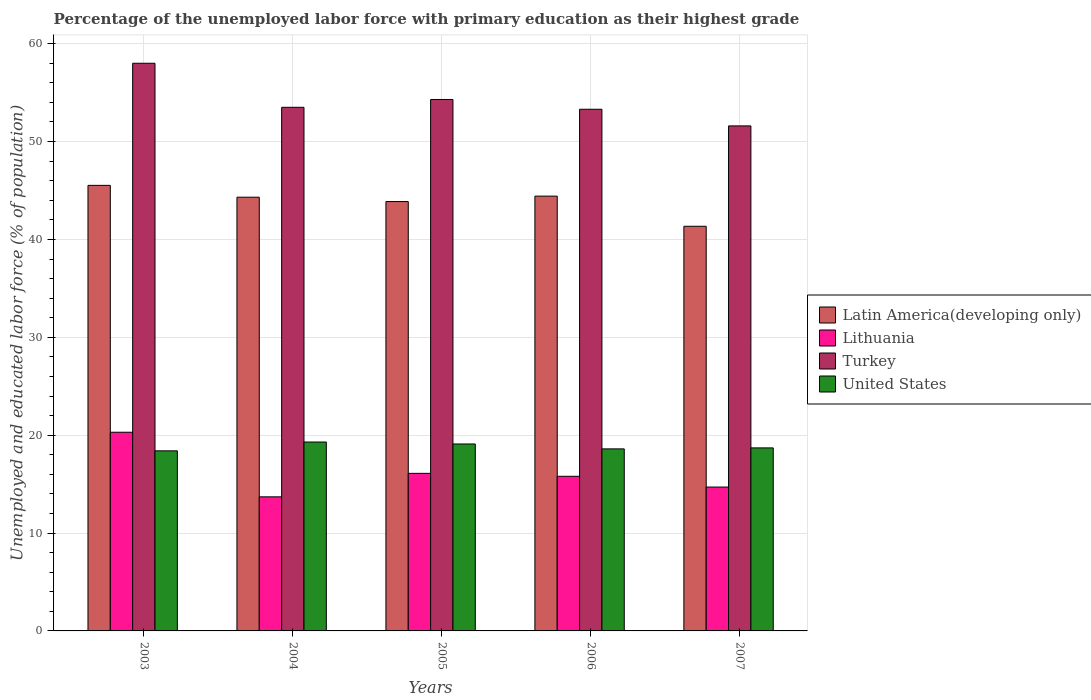How many groups of bars are there?
Ensure brevity in your answer.  5. How many bars are there on the 2nd tick from the left?
Your answer should be very brief. 4. In how many cases, is the number of bars for a given year not equal to the number of legend labels?
Offer a terse response. 0. What is the percentage of the unemployed labor force with primary education in United States in 2007?
Provide a short and direct response. 18.7. Across all years, what is the maximum percentage of the unemployed labor force with primary education in Latin America(developing only)?
Your answer should be very brief. 45.52. Across all years, what is the minimum percentage of the unemployed labor force with primary education in Latin America(developing only)?
Provide a short and direct response. 41.34. In which year was the percentage of the unemployed labor force with primary education in United States minimum?
Offer a very short reply. 2003. What is the total percentage of the unemployed labor force with primary education in Turkey in the graph?
Give a very brief answer. 270.7. What is the difference between the percentage of the unemployed labor force with primary education in Lithuania in 2003 and that in 2006?
Keep it short and to the point. 4.5. What is the difference between the percentage of the unemployed labor force with primary education in Lithuania in 2007 and the percentage of the unemployed labor force with primary education in Turkey in 2005?
Your answer should be compact. -39.6. What is the average percentage of the unemployed labor force with primary education in United States per year?
Your answer should be compact. 18.82. In the year 2005, what is the difference between the percentage of the unemployed labor force with primary education in Latin America(developing only) and percentage of the unemployed labor force with primary education in United States?
Provide a succinct answer. 24.77. What is the ratio of the percentage of the unemployed labor force with primary education in Latin America(developing only) in 2003 to that in 2007?
Ensure brevity in your answer.  1.1. Is the percentage of the unemployed labor force with primary education in Lithuania in 2004 less than that in 2005?
Make the answer very short. Yes. Is the difference between the percentage of the unemployed labor force with primary education in Latin America(developing only) in 2003 and 2007 greater than the difference between the percentage of the unemployed labor force with primary education in United States in 2003 and 2007?
Your response must be concise. Yes. What is the difference between the highest and the second highest percentage of the unemployed labor force with primary education in Latin America(developing only)?
Keep it short and to the point. 1.1. What is the difference between the highest and the lowest percentage of the unemployed labor force with primary education in United States?
Offer a very short reply. 0.9. Is the sum of the percentage of the unemployed labor force with primary education in United States in 2003 and 2005 greater than the maximum percentage of the unemployed labor force with primary education in Lithuania across all years?
Your answer should be very brief. Yes. What does the 2nd bar from the left in 2003 represents?
Your answer should be very brief. Lithuania. What does the 4th bar from the right in 2004 represents?
Ensure brevity in your answer.  Latin America(developing only). How many years are there in the graph?
Offer a terse response. 5. What is the difference between two consecutive major ticks on the Y-axis?
Provide a succinct answer. 10. Are the values on the major ticks of Y-axis written in scientific E-notation?
Make the answer very short. No. Does the graph contain any zero values?
Provide a short and direct response. No. Does the graph contain grids?
Make the answer very short. Yes. Where does the legend appear in the graph?
Make the answer very short. Center right. How are the legend labels stacked?
Provide a succinct answer. Vertical. What is the title of the graph?
Keep it short and to the point. Percentage of the unemployed labor force with primary education as their highest grade. What is the label or title of the Y-axis?
Provide a short and direct response. Unemployed and educated labor force (% of population). What is the Unemployed and educated labor force (% of population) in Latin America(developing only) in 2003?
Keep it short and to the point. 45.52. What is the Unemployed and educated labor force (% of population) of Lithuania in 2003?
Your response must be concise. 20.3. What is the Unemployed and educated labor force (% of population) of Turkey in 2003?
Your answer should be very brief. 58. What is the Unemployed and educated labor force (% of population) in United States in 2003?
Ensure brevity in your answer.  18.4. What is the Unemployed and educated labor force (% of population) in Latin America(developing only) in 2004?
Keep it short and to the point. 44.32. What is the Unemployed and educated labor force (% of population) of Lithuania in 2004?
Offer a very short reply. 13.7. What is the Unemployed and educated labor force (% of population) in Turkey in 2004?
Ensure brevity in your answer.  53.5. What is the Unemployed and educated labor force (% of population) of United States in 2004?
Make the answer very short. 19.3. What is the Unemployed and educated labor force (% of population) in Latin America(developing only) in 2005?
Provide a short and direct response. 43.87. What is the Unemployed and educated labor force (% of population) in Lithuania in 2005?
Provide a short and direct response. 16.1. What is the Unemployed and educated labor force (% of population) of Turkey in 2005?
Provide a short and direct response. 54.3. What is the Unemployed and educated labor force (% of population) in United States in 2005?
Ensure brevity in your answer.  19.1. What is the Unemployed and educated labor force (% of population) of Latin America(developing only) in 2006?
Your response must be concise. 44.42. What is the Unemployed and educated labor force (% of population) of Lithuania in 2006?
Keep it short and to the point. 15.8. What is the Unemployed and educated labor force (% of population) of Turkey in 2006?
Keep it short and to the point. 53.3. What is the Unemployed and educated labor force (% of population) in United States in 2006?
Give a very brief answer. 18.6. What is the Unemployed and educated labor force (% of population) in Latin America(developing only) in 2007?
Your response must be concise. 41.34. What is the Unemployed and educated labor force (% of population) of Lithuania in 2007?
Provide a short and direct response. 14.7. What is the Unemployed and educated labor force (% of population) of Turkey in 2007?
Your response must be concise. 51.6. What is the Unemployed and educated labor force (% of population) in United States in 2007?
Your answer should be very brief. 18.7. Across all years, what is the maximum Unemployed and educated labor force (% of population) in Latin America(developing only)?
Your response must be concise. 45.52. Across all years, what is the maximum Unemployed and educated labor force (% of population) in Lithuania?
Offer a terse response. 20.3. Across all years, what is the maximum Unemployed and educated labor force (% of population) of Turkey?
Provide a short and direct response. 58. Across all years, what is the maximum Unemployed and educated labor force (% of population) in United States?
Give a very brief answer. 19.3. Across all years, what is the minimum Unemployed and educated labor force (% of population) of Latin America(developing only)?
Keep it short and to the point. 41.34. Across all years, what is the minimum Unemployed and educated labor force (% of population) of Lithuania?
Your answer should be very brief. 13.7. Across all years, what is the minimum Unemployed and educated labor force (% of population) of Turkey?
Make the answer very short. 51.6. Across all years, what is the minimum Unemployed and educated labor force (% of population) in United States?
Offer a very short reply. 18.4. What is the total Unemployed and educated labor force (% of population) in Latin America(developing only) in the graph?
Keep it short and to the point. 219.48. What is the total Unemployed and educated labor force (% of population) of Lithuania in the graph?
Provide a succinct answer. 80.6. What is the total Unemployed and educated labor force (% of population) in Turkey in the graph?
Your answer should be compact. 270.7. What is the total Unemployed and educated labor force (% of population) in United States in the graph?
Offer a very short reply. 94.1. What is the difference between the Unemployed and educated labor force (% of population) of Latin America(developing only) in 2003 and that in 2004?
Keep it short and to the point. 1.21. What is the difference between the Unemployed and educated labor force (% of population) in Lithuania in 2003 and that in 2004?
Your answer should be very brief. 6.6. What is the difference between the Unemployed and educated labor force (% of population) of Latin America(developing only) in 2003 and that in 2005?
Your answer should be compact. 1.65. What is the difference between the Unemployed and educated labor force (% of population) of Turkey in 2003 and that in 2005?
Your response must be concise. 3.7. What is the difference between the Unemployed and educated labor force (% of population) in United States in 2003 and that in 2005?
Provide a succinct answer. -0.7. What is the difference between the Unemployed and educated labor force (% of population) in Latin America(developing only) in 2003 and that in 2006?
Your answer should be compact. 1.1. What is the difference between the Unemployed and educated labor force (% of population) in Lithuania in 2003 and that in 2006?
Offer a terse response. 4.5. What is the difference between the Unemployed and educated labor force (% of population) of Turkey in 2003 and that in 2006?
Offer a terse response. 4.7. What is the difference between the Unemployed and educated labor force (% of population) in United States in 2003 and that in 2006?
Your response must be concise. -0.2. What is the difference between the Unemployed and educated labor force (% of population) in Latin America(developing only) in 2003 and that in 2007?
Your answer should be very brief. 4.18. What is the difference between the Unemployed and educated labor force (% of population) of Latin America(developing only) in 2004 and that in 2005?
Provide a succinct answer. 0.44. What is the difference between the Unemployed and educated labor force (% of population) in Lithuania in 2004 and that in 2005?
Your answer should be very brief. -2.4. What is the difference between the Unemployed and educated labor force (% of population) in Turkey in 2004 and that in 2005?
Give a very brief answer. -0.8. What is the difference between the Unemployed and educated labor force (% of population) of United States in 2004 and that in 2005?
Provide a succinct answer. 0.2. What is the difference between the Unemployed and educated labor force (% of population) of Latin America(developing only) in 2004 and that in 2006?
Your answer should be compact. -0.11. What is the difference between the Unemployed and educated labor force (% of population) of Latin America(developing only) in 2004 and that in 2007?
Provide a succinct answer. 2.97. What is the difference between the Unemployed and educated labor force (% of population) of Lithuania in 2004 and that in 2007?
Provide a succinct answer. -1. What is the difference between the Unemployed and educated labor force (% of population) of Turkey in 2004 and that in 2007?
Offer a terse response. 1.9. What is the difference between the Unemployed and educated labor force (% of population) in Latin America(developing only) in 2005 and that in 2006?
Your response must be concise. -0.55. What is the difference between the Unemployed and educated labor force (% of population) in Turkey in 2005 and that in 2006?
Your response must be concise. 1. What is the difference between the Unemployed and educated labor force (% of population) of United States in 2005 and that in 2006?
Provide a short and direct response. 0.5. What is the difference between the Unemployed and educated labor force (% of population) in Latin America(developing only) in 2005 and that in 2007?
Ensure brevity in your answer.  2.53. What is the difference between the Unemployed and educated labor force (% of population) of Turkey in 2005 and that in 2007?
Ensure brevity in your answer.  2.7. What is the difference between the Unemployed and educated labor force (% of population) in United States in 2005 and that in 2007?
Keep it short and to the point. 0.4. What is the difference between the Unemployed and educated labor force (% of population) of Latin America(developing only) in 2006 and that in 2007?
Ensure brevity in your answer.  3.08. What is the difference between the Unemployed and educated labor force (% of population) in Lithuania in 2006 and that in 2007?
Offer a terse response. 1.1. What is the difference between the Unemployed and educated labor force (% of population) in United States in 2006 and that in 2007?
Ensure brevity in your answer.  -0.1. What is the difference between the Unemployed and educated labor force (% of population) in Latin America(developing only) in 2003 and the Unemployed and educated labor force (% of population) in Lithuania in 2004?
Your answer should be compact. 31.82. What is the difference between the Unemployed and educated labor force (% of population) in Latin America(developing only) in 2003 and the Unemployed and educated labor force (% of population) in Turkey in 2004?
Ensure brevity in your answer.  -7.98. What is the difference between the Unemployed and educated labor force (% of population) in Latin America(developing only) in 2003 and the Unemployed and educated labor force (% of population) in United States in 2004?
Make the answer very short. 26.22. What is the difference between the Unemployed and educated labor force (% of population) in Lithuania in 2003 and the Unemployed and educated labor force (% of population) in Turkey in 2004?
Your response must be concise. -33.2. What is the difference between the Unemployed and educated labor force (% of population) in Turkey in 2003 and the Unemployed and educated labor force (% of population) in United States in 2004?
Provide a short and direct response. 38.7. What is the difference between the Unemployed and educated labor force (% of population) in Latin America(developing only) in 2003 and the Unemployed and educated labor force (% of population) in Lithuania in 2005?
Offer a terse response. 29.42. What is the difference between the Unemployed and educated labor force (% of population) of Latin America(developing only) in 2003 and the Unemployed and educated labor force (% of population) of Turkey in 2005?
Ensure brevity in your answer.  -8.78. What is the difference between the Unemployed and educated labor force (% of population) in Latin America(developing only) in 2003 and the Unemployed and educated labor force (% of population) in United States in 2005?
Your answer should be very brief. 26.42. What is the difference between the Unemployed and educated labor force (% of population) of Lithuania in 2003 and the Unemployed and educated labor force (% of population) of Turkey in 2005?
Make the answer very short. -34. What is the difference between the Unemployed and educated labor force (% of population) in Turkey in 2003 and the Unemployed and educated labor force (% of population) in United States in 2005?
Provide a short and direct response. 38.9. What is the difference between the Unemployed and educated labor force (% of population) of Latin America(developing only) in 2003 and the Unemployed and educated labor force (% of population) of Lithuania in 2006?
Keep it short and to the point. 29.72. What is the difference between the Unemployed and educated labor force (% of population) in Latin America(developing only) in 2003 and the Unemployed and educated labor force (% of population) in Turkey in 2006?
Give a very brief answer. -7.78. What is the difference between the Unemployed and educated labor force (% of population) of Latin America(developing only) in 2003 and the Unemployed and educated labor force (% of population) of United States in 2006?
Your answer should be compact. 26.92. What is the difference between the Unemployed and educated labor force (% of population) in Lithuania in 2003 and the Unemployed and educated labor force (% of population) in Turkey in 2006?
Your answer should be very brief. -33. What is the difference between the Unemployed and educated labor force (% of population) in Lithuania in 2003 and the Unemployed and educated labor force (% of population) in United States in 2006?
Provide a short and direct response. 1.7. What is the difference between the Unemployed and educated labor force (% of population) in Turkey in 2003 and the Unemployed and educated labor force (% of population) in United States in 2006?
Keep it short and to the point. 39.4. What is the difference between the Unemployed and educated labor force (% of population) in Latin America(developing only) in 2003 and the Unemployed and educated labor force (% of population) in Lithuania in 2007?
Provide a short and direct response. 30.82. What is the difference between the Unemployed and educated labor force (% of population) in Latin America(developing only) in 2003 and the Unemployed and educated labor force (% of population) in Turkey in 2007?
Give a very brief answer. -6.08. What is the difference between the Unemployed and educated labor force (% of population) of Latin America(developing only) in 2003 and the Unemployed and educated labor force (% of population) of United States in 2007?
Make the answer very short. 26.82. What is the difference between the Unemployed and educated labor force (% of population) in Lithuania in 2003 and the Unemployed and educated labor force (% of population) in Turkey in 2007?
Your response must be concise. -31.3. What is the difference between the Unemployed and educated labor force (% of population) in Lithuania in 2003 and the Unemployed and educated labor force (% of population) in United States in 2007?
Give a very brief answer. 1.6. What is the difference between the Unemployed and educated labor force (% of population) of Turkey in 2003 and the Unemployed and educated labor force (% of population) of United States in 2007?
Your answer should be very brief. 39.3. What is the difference between the Unemployed and educated labor force (% of population) of Latin America(developing only) in 2004 and the Unemployed and educated labor force (% of population) of Lithuania in 2005?
Give a very brief answer. 28.22. What is the difference between the Unemployed and educated labor force (% of population) of Latin America(developing only) in 2004 and the Unemployed and educated labor force (% of population) of Turkey in 2005?
Keep it short and to the point. -9.98. What is the difference between the Unemployed and educated labor force (% of population) in Latin America(developing only) in 2004 and the Unemployed and educated labor force (% of population) in United States in 2005?
Provide a short and direct response. 25.22. What is the difference between the Unemployed and educated labor force (% of population) in Lithuania in 2004 and the Unemployed and educated labor force (% of population) in Turkey in 2005?
Provide a short and direct response. -40.6. What is the difference between the Unemployed and educated labor force (% of population) in Lithuania in 2004 and the Unemployed and educated labor force (% of population) in United States in 2005?
Keep it short and to the point. -5.4. What is the difference between the Unemployed and educated labor force (% of population) of Turkey in 2004 and the Unemployed and educated labor force (% of population) of United States in 2005?
Your answer should be compact. 34.4. What is the difference between the Unemployed and educated labor force (% of population) in Latin America(developing only) in 2004 and the Unemployed and educated labor force (% of population) in Lithuania in 2006?
Your response must be concise. 28.52. What is the difference between the Unemployed and educated labor force (% of population) in Latin America(developing only) in 2004 and the Unemployed and educated labor force (% of population) in Turkey in 2006?
Keep it short and to the point. -8.98. What is the difference between the Unemployed and educated labor force (% of population) of Latin America(developing only) in 2004 and the Unemployed and educated labor force (% of population) of United States in 2006?
Offer a terse response. 25.72. What is the difference between the Unemployed and educated labor force (% of population) of Lithuania in 2004 and the Unemployed and educated labor force (% of population) of Turkey in 2006?
Your answer should be very brief. -39.6. What is the difference between the Unemployed and educated labor force (% of population) of Lithuania in 2004 and the Unemployed and educated labor force (% of population) of United States in 2006?
Your answer should be compact. -4.9. What is the difference between the Unemployed and educated labor force (% of population) of Turkey in 2004 and the Unemployed and educated labor force (% of population) of United States in 2006?
Provide a succinct answer. 34.9. What is the difference between the Unemployed and educated labor force (% of population) of Latin America(developing only) in 2004 and the Unemployed and educated labor force (% of population) of Lithuania in 2007?
Your response must be concise. 29.62. What is the difference between the Unemployed and educated labor force (% of population) of Latin America(developing only) in 2004 and the Unemployed and educated labor force (% of population) of Turkey in 2007?
Ensure brevity in your answer.  -7.28. What is the difference between the Unemployed and educated labor force (% of population) of Latin America(developing only) in 2004 and the Unemployed and educated labor force (% of population) of United States in 2007?
Keep it short and to the point. 25.62. What is the difference between the Unemployed and educated labor force (% of population) in Lithuania in 2004 and the Unemployed and educated labor force (% of population) in Turkey in 2007?
Make the answer very short. -37.9. What is the difference between the Unemployed and educated labor force (% of population) in Turkey in 2004 and the Unemployed and educated labor force (% of population) in United States in 2007?
Offer a terse response. 34.8. What is the difference between the Unemployed and educated labor force (% of population) in Latin America(developing only) in 2005 and the Unemployed and educated labor force (% of population) in Lithuania in 2006?
Your answer should be compact. 28.07. What is the difference between the Unemployed and educated labor force (% of population) in Latin America(developing only) in 2005 and the Unemployed and educated labor force (% of population) in Turkey in 2006?
Keep it short and to the point. -9.43. What is the difference between the Unemployed and educated labor force (% of population) in Latin America(developing only) in 2005 and the Unemployed and educated labor force (% of population) in United States in 2006?
Your answer should be very brief. 25.27. What is the difference between the Unemployed and educated labor force (% of population) of Lithuania in 2005 and the Unemployed and educated labor force (% of population) of Turkey in 2006?
Give a very brief answer. -37.2. What is the difference between the Unemployed and educated labor force (% of population) in Lithuania in 2005 and the Unemployed and educated labor force (% of population) in United States in 2006?
Your response must be concise. -2.5. What is the difference between the Unemployed and educated labor force (% of population) in Turkey in 2005 and the Unemployed and educated labor force (% of population) in United States in 2006?
Offer a very short reply. 35.7. What is the difference between the Unemployed and educated labor force (% of population) of Latin America(developing only) in 2005 and the Unemployed and educated labor force (% of population) of Lithuania in 2007?
Provide a short and direct response. 29.17. What is the difference between the Unemployed and educated labor force (% of population) in Latin America(developing only) in 2005 and the Unemployed and educated labor force (% of population) in Turkey in 2007?
Your answer should be compact. -7.73. What is the difference between the Unemployed and educated labor force (% of population) of Latin America(developing only) in 2005 and the Unemployed and educated labor force (% of population) of United States in 2007?
Offer a terse response. 25.17. What is the difference between the Unemployed and educated labor force (% of population) of Lithuania in 2005 and the Unemployed and educated labor force (% of population) of Turkey in 2007?
Give a very brief answer. -35.5. What is the difference between the Unemployed and educated labor force (% of population) in Lithuania in 2005 and the Unemployed and educated labor force (% of population) in United States in 2007?
Give a very brief answer. -2.6. What is the difference between the Unemployed and educated labor force (% of population) of Turkey in 2005 and the Unemployed and educated labor force (% of population) of United States in 2007?
Offer a very short reply. 35.6. What is the difference between the Unemployed and educated labor force (% of population) in Latin America(developing only) in 2006 and the Unemployed and educated labor force (% of population) in Lithuania in 2007?
Offer a very short reply. 29.72. What is the difference between the Unemployed and educated labor force (% of population) of Latin America(developing only) in 2006 and the Unemployed and educated labor force (% of population) of Turkey in 2007?
Offer a very short reply. -7.18. What is the difference between the Unemployed and educated labor force (% of population) in Latin America(developing only) in 2006 and the Unemployed and educated labor force (% of population) in United States in 2007?
Offer a very short reply. 25.72. What is the difference between the Unemployed and educated labor force (% of population) in Lithuania in 2006 and the Unemployed and educated labor force (% of population) in Turkey in 2007?
Keep it short and to the point. -35.8. What is the difference between the Unemployed and educated labor force (% of population) in Turkey in 2006 and the Unemployed and educated labor force (% of population) in United States in 2007?
Your answer should be very brief. 34.6. What is the average Unemployed and educated labor force (% of population) of Latin America(developing only) per year?
Your response must be concise. 43.9. What is the average Unemployed and educated labor force (% of population) in Lithuania per year?
Keep it short and to the point. 16.12. What is the average Unemployed and educated labor force (% of population) in Turkey per year?
Give a very brief answer. 54.14. What is the average Unemployed and educated labor force (% of population) of United States per year?
Ensure brevity in your answer.  18.82. In the year 2003, what is the difference between the Unemployed and educated labor force (% of population) in Latin America(developing only) and Unemployed and educated labor force (% of population) in Lithuania?
Provide a short and direct response. 25.22. In the year 2003, what is the difference between the Unemployed and educated labor force (% of population) of Latin America(developing only) and Unemployed and educated labor force (% of population) of Turkey?
Make the answer very short. -12.48. In the year 2003, what is the difference between the Unemployed and educated labor force (% of population) in Latin America(developing only) and Unemployed and educated labor force (% of population) in United States?
Your answer should be very brief. 27.12. In the year 2003, what is the difference between the Unemployed and educated labor force (% of population) of Lithuania and Unemployed and educated labor force (% of population) of Turkey?
Your response must be concise. -37.7. In the year 2003, what is the difference between the Unemployed and educated labor force (% of population) in Turkey and Unemployed and educated labor force (% of population) in United States?
Make the answer very short. 39.6. In the year 2004, what is the difference between the Unemployed and educated labor force (% of population) of Latin America(developing only) and Unemployed and educated labor force (% of population) of Lithuania?
Your answer should be compact. 30.62. In the year 2004, what is the difference between the Unemployed and educated labor force (% of population) of Latin America(developing only) and Unemployed and educated labor force (% of population) of Turkey?
Ensure brevity in your answer.  -9.18. In the year 2004, what is the difference between the Unemployed and educated labor force (% of population) in Latin America(developing only) and Unemployed and educated labor force (% of population) in United States?
Provide a succinct answer. 25.02. In the year 2004, what is the difference between the Unemployed and educated labor force (% of population) in Lithuania and Unemployed and educated labor force (% of population) in Turkey?
Offer a terse response. -39.8. In the year 2004, what is the difference between the Unemployed and educated labor force (% of population) in Turkey and Unemployed and educated labor force (% of population) in United States?
Your response must be concise. 34.2. In the year 2005, what is the difference between the Unemployed and educated labor force (% of population) of Latin America(developing only) and Unemployed and educated labor force (% of population) of Lithuania?
Make the answer very short. 27.77. In the year 2005, what is the difference between the Unemployed and educated labor force (% of population) of Latin America(developing only) and Unemployed and educated labor force (% of population) of Turkey?
Your answer should be compact. -10.43. In the year 2005, what is the difference between the Unemployed and educated labor force (% of population) of Latin America(developing only) and Unemployed and educated labor force (% of population) of United States?
Offer a very short reply. 24.77. In the year 2005, what is the difference between the Unemployed and educated labor force (% of population) in Lithuania and Unemployed and educated labor force (% of population) in Turkey?
Provide a succinct answer. -38.2. In the year 2005, what is the difference between the Unemployed and educated labor force (% of population) in Lithuania and Unemployed and educated labor force (% of population) in United States?
Offer a very short reply. -3. In the year 2005, what is the difference between the Unemployed and educated labor force (% of population) of Turkey and Unemployed and educated labor force (% of population) of United States?
Provide a short and direct response. 35.2. In the year 2006, what is the difference between the Unemployed and educated labor force (% of population) of Latin America(developing only) and Unemployed and educated labor force (% of population) of Lithuania?
Offer a terse response. 28.62. In the year 2006, what is the difference between the Unemployed and educated labor force (% of population) in Latin America(developing only) and Unemployed and educated labor force (% of population) in Turkey?
Your answer should be compact. -8.88. In the year 2006, what is the difference between the Unemployed and educated labor force (% of population) of Latin America(developing only) and Unemployed and educated labor force (% of population) of United States?
Keep it short and to the point. 25.82. In the year 2006, what is the difference between the Unemployed and educated labor force (% of population) in Lithuania and Unemployed and educated labor force (% of population) in Turkey?
Provide a succinct answer. -37.5. In the year 2006, what is the difference between the Unemployed and educated labor force (% of population) of Lithuania and Unemployed and educated labor force (% of population) of United States?
Provide a short and direct response. -2.8. In the year 2006, what is the difference between the Unemployed and educated labor force (% of population) of Turkey and Unemployed and educated labor force (% of population) of United States?
Your answer should be very brief. 34.7. In the year 2007, what is the difference between the Unemployed and educated labor force (% of population) of Latin America(developing only) and Unemployed and educated labor force (% of population) of Lithuania?
Offer a terse response. 26.64. In the year 2007, what is the difference between the Unemployed and educated labor force (% of population) in Latin America(developing only) and Unemployed and educated labor force (% of population) in Turkey?
Offer a very short reply. -10.26. In the year 2007, what is the difference between the Unemployed and educated labor force (% of population) in Latin America(developing only) and Unemployed and educated labor force (% of population) in United States?
Your response must be concise. 22.64. In the year 2007, what is the difference between the Unemployed and educated labor force (% of population) in Lithuania and Unemployed and educated labor force (% of population) in Turkey?
Keep it short and to the point. -36.9. In the year 2007, what is the difference between the Unemployed and educated labor force (% of population) in Turkey and Unemployed and educated labor force (% of population) in United States?
Keep it short and to the point. 32.9. What is the ratio of the Unemployed and educated labor force (% of population) of Latin America(developing only) in 2003 to that in 2004?
Keep it short and to the point. 1.03. What is the ratio of the Unemployed and educated labor force (% of population) of Lithuania in 2003 to that in 2004?
Offer a terse response. 1.48. What is the ratio of the Unemployed and educated labor force (% of population) in Turkey in 2003 to that in 2004?
Make the answer very short. 1.08. What is the ratio of the Unemployed and educated labor force (% of population) of United States in 2003 to that in 2004?
Ensure brevity in your answer.  0.95. What is the ratio of the Unemployed and educated labor force (% of population) in Latin America(developing only) in 2003 to that in 2005?
Your answer should be very brief. 1.04. What is the ratio of the Unemployed and educated labor force (% of population) of Lithuania in 2003 to that in 2005?
Keep it short and to the point. 1.26. What is the ratio of the Unemployed and educated labor force (% of population) in Turkey in 2003 to that in 2005?
Keep it short and to the point. 1.07. What is the ratio of the Unemployed and educated labor force (% of population) in United States in 2003 to that in 2005?
Your answer should be very brief. 0.96. What is the ratio of the Unemployed and educated labor force (% of population) of Latin America(developing only) in 2003 to that in 2006?
Provide a succinct answer. 1.02. What is the ratio of the Unemployed and educated labor force (% of population) in Lithuania in 2003 to that in 2006?
Make the answer very short. 1.28. What is the ratio of the Unemployed and educated labor force (% of population) of Turkey in 2003 to that in 2006?
Your answer should be very brief. 1.09. What is the ratio of the Unemployed and educated labor force (% of population) in United States in 2003 to that in 2006?
Your response must be concise. 0.99. What is the ratio of the Unemployed and educated labor force (% of population) in Latin America(developing only) in 2003 to that in 2007?
Make the answer very short. 1.1. What is the ratio of the Unemployed and educated labor force (% of population) in Lithuania in 2003 to that in 2007?
Give a very brief answer. 1.38. What is the ratio of the Unemployed and educated labor force (% of population) of Turkey in 2003 to that in 2007?
Make the answer very short. 1.12. What is the ratio of the Unemployed and educated labor force (% of population) in United States in 2003 to that in 2007?
Your response must be concise. 0.98. What is the ratio of the Unemployed and educated labor force (% of population) in Latin America(developing only) in 2004 to that in 2005?
Provide a short and direct response. 1.01. What is the ratio of the Unemployed and educated labor force (% of population) of Lithuania in 2004 to that in 2005?
Your answer should be very brief. 0.85. What is the ratio of the Unemployed and educated labor force (% of population) of Turkey in 2004 to that in 2005?
Provide a short and direct response. 0.99. What is the ratio of the Unemployed and educated labor force (% of population) of United States in 2004 to that in 2005?
Offer a terse response. 1.01. What is the ratio of the Unemployed and educated labor force (% of population) in Latin America(developing only) in 2004 to that in 2006?
Ensure brevity in your answer.  1. What is the ratio of the Unemployed and educated labor force (% of population) in Lithuania in 2004 to that in 2006?
Your answer should be compact. 0.87. What is the ratio of the Unemployed and educated labor force (% of population) in Turkey in 2004 to that in 2006?
Offer a very short reply. 1. What is the ratio of the Unemployed and educated labor force (% of population) of United States in 2004 to that in 2006?
Make the answer very short. 1.04. What is the ratio of the Unemployed and educated labor force (% of population) in Latin America(developing only) in 2004 to that in 2007?
Give a very brief answer. 1.07. What is the ratio of the Unemployed and educated labor force (% of population) in Lithuania in 2004 to that in 2007?
Offer a very short reply. 0.93. What is the ratio of the Unemployed and educated labor force (% of population) in Turkey in 2004 to that in 2007?
Provide a succinct answer. 1.04. What is the ratio of the Unemployed and educated labor force (% of population) of United States in 2004 to that in 2007?
Your response must be concise. 1.03. What is the ratio of the Unemployed and educated labor force (% of population) of Latin America(developing only) in 2005 to that in 2006?
Keep it short and to the point. 0.99. What is the ratio of the Unemployed and educated labor force (% of population) of Turkey in 2005 to that in 2006?
Give a very brief answer. 1.02. What is the ratio of the Unemployed and educated labor force (% of population) in United States in 2005 to that in 2006?
Provide a short and direct response. 1.03. What is the ratio of the Unemployed and educated labor force (% of population) in Latin America(developing only) in 2005 to that in 2007?
Your answer should be compact. 1.06. What is the ratio of the Unemployed and educated labor force (% of population) of Lithuania in 2005 to that in 2007?
Offer a very short reply. 1.1. What is the ratio of the Unemployed and educated labor force (% of population) of Turkey in 2005 to that in 2007?
Your answer should be compact. 1.05. What is the ratio of the Unemployed and educated labor force (% of population) in United States in 2005 to that in 2007?
Offer a terse response. 1.02. What is the ratio of the Unemployed and educated labor force (% of population) in Latin America(developing only) in 2006 to that in 2007?
Provide a succinct answer. 1.07. What is the ratio of the Unemployed and educated labor force (% of population) in Lithuania in 2006 to that in 2007?
Ensure brevity in your answer.  1.07. What is the ratio of the Unemployed and educated labor force (% of population) in Turkey in 2006 to that in 2007?
Make the answer very short. 1.03. What is the difference between the highest and the second highest Unemployed and educated labor force (% of population) of Latin America(developing only)?
Provide a succinct answer. 1.1. What is the difference between the highest and the second highest Unemployed and educated labor force (% of population) of Lithuania?
Give a very brief answer. 4.2. What is the difference between the highest and the second highest Unemployed and educated labor force (% of population) in Turkey?
Offer a very short reply. 3.7. What is the difference between the highest and the second highest Unemployed and educated labor force (% of population) of United States?
Keep it short and to the point. 0.2. What is the difference between the highest and the lowest Unemployed and educated labor force (% of population) of Latin America(developing only)?
Your response must be concise. 4.18. What is the difference between the highest and the lowest Unemployed and educated labor force (% of population) in Lithuania?
Make the answer very short. 6.6. What is the difference between the highest and the lowest Unemployed and educated labor force (% of population) in United States?
Your answer should be compact. 0.9. 